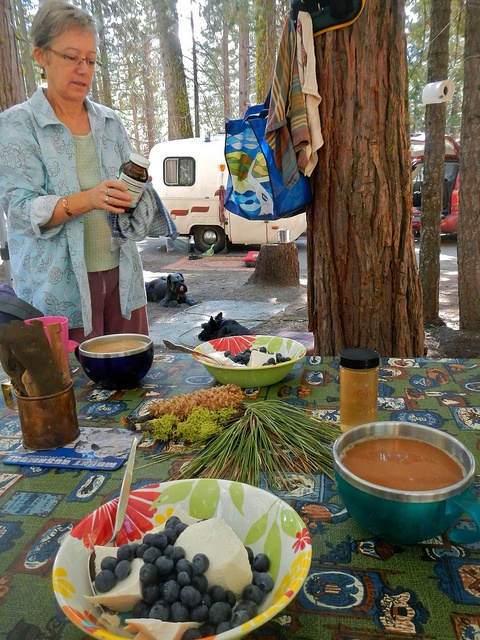Describe the objects in this image and their specific colors. I can see dining table in gray, black, olive, and darkgray tones, people in gray, darkgray, and salmon tones, bowl in gray, black, darkgray, and olive tones, bowl in gray, brown, black, and teal tones, and truck in gray, white, tan, and black tones in this image. 